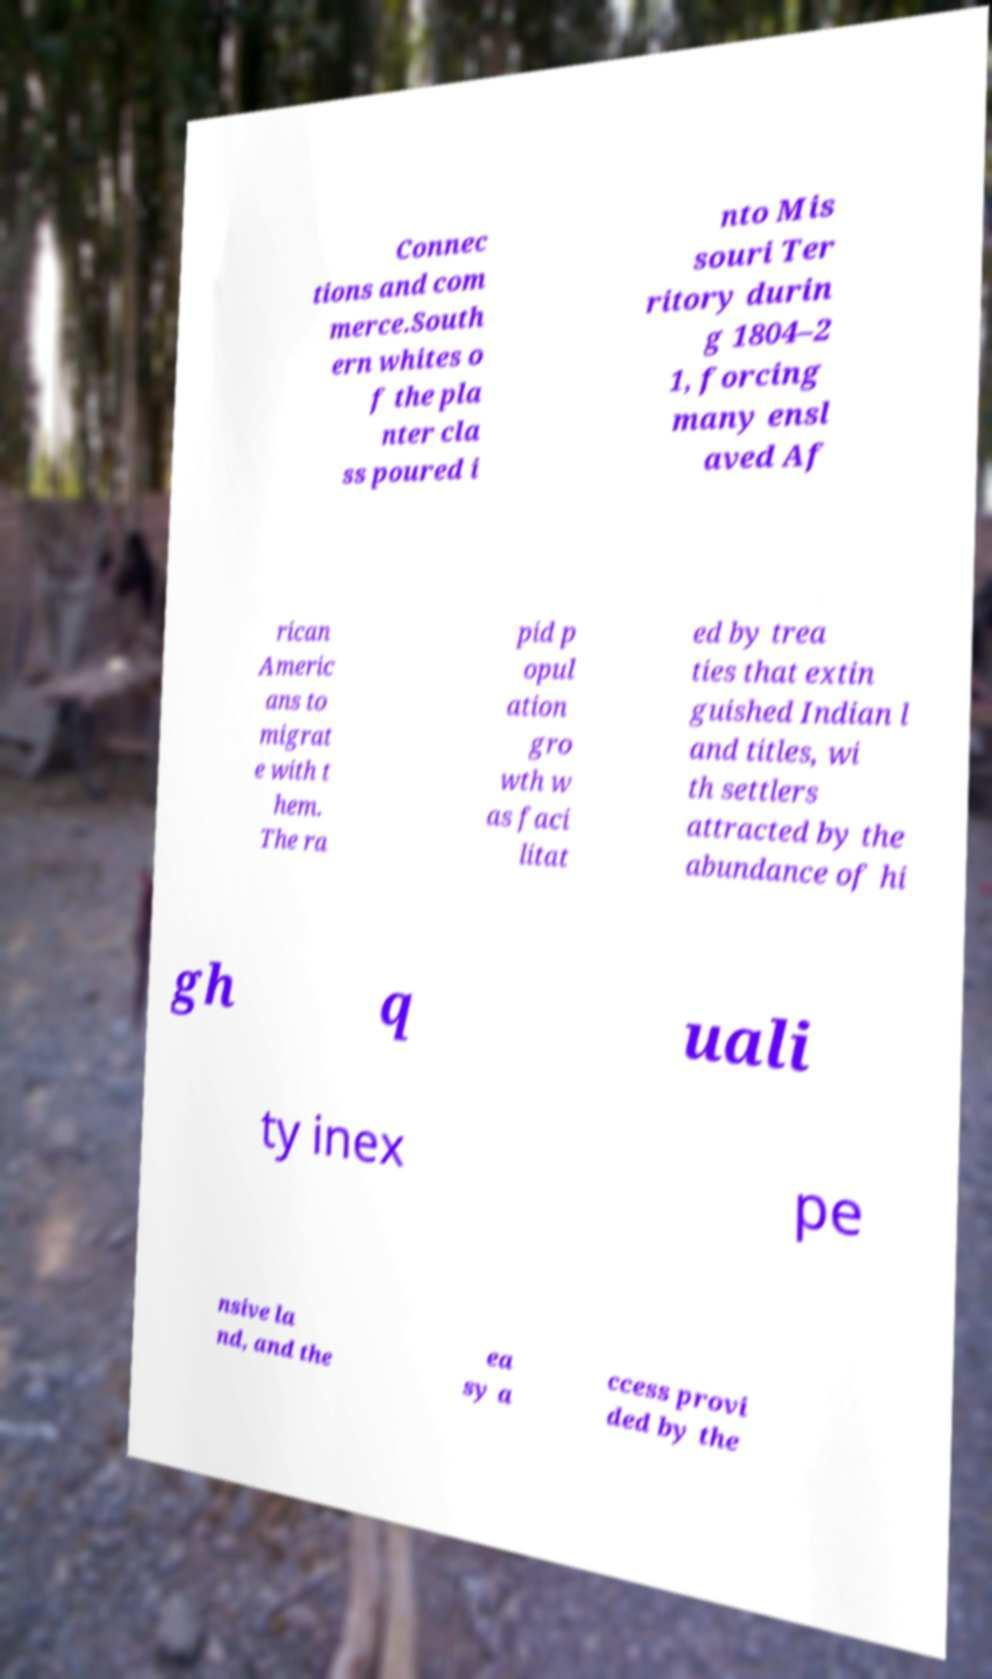Can you accurately transcribe the text from the provided image for me? Connec tions and com merce.South ern whites o f the pla nter cla ss poured i nto Mis souri Ter ritory durin g 1804–2 1, forcing many ensl aved Af rican Americ ans to migrat e with t hem. The ra pid p opul ation gro wth w as faci litat ed by trea ties that extin guished Indian l and titles, wi th settlers attracted by the abundance of hi gh q uali ty inex pe nsive la nd, and the ea sy a ccess provi ded by the 